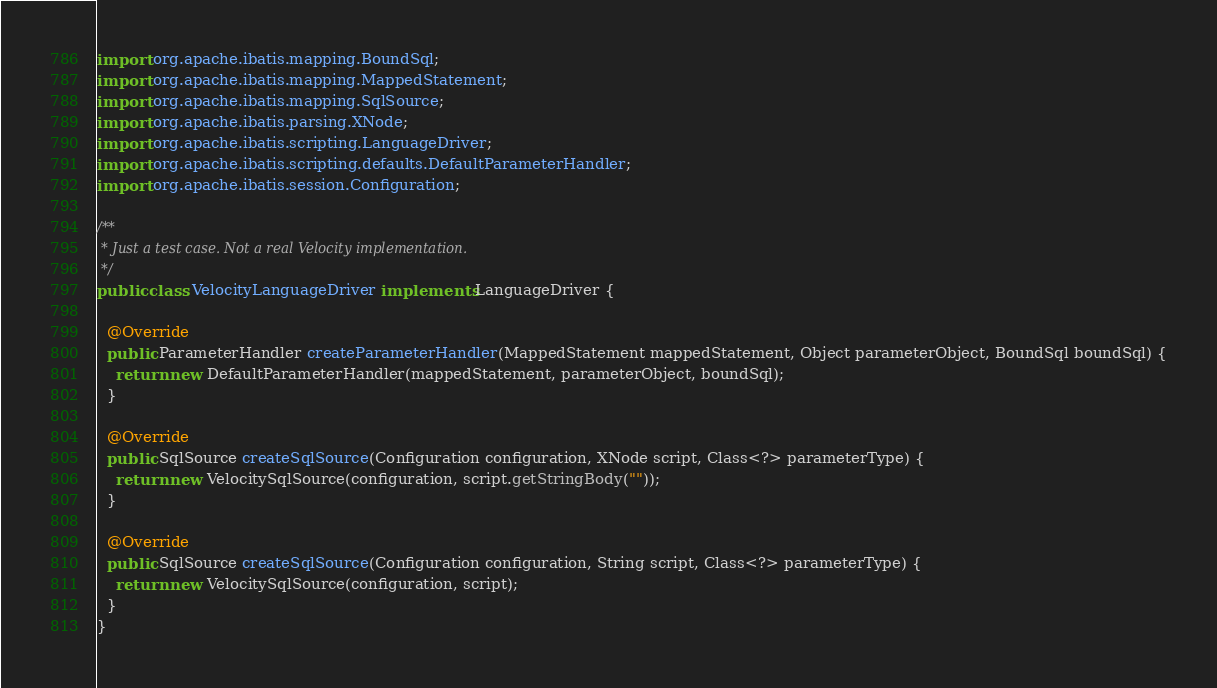Convert code to text. <code><loc_0><loc_0><loc_500><loc_500><_Java_>import org.apache.ibatis.mapping.BoundSql;
import org.apache.ibatis.mapping.MappedStatement;
import org.apache.ibatis.mapping.SqlSource;
import org.apache.ibatis.parsing.XNode;
import org.apache.ibatis.scripting.LanguageDriver;
import org.apache.ibatis.scripting.defaults.DefaultParameterHandler;
import org.apache.ibatis.session.Configuration;

/**
 * Just a test case. Not a real Velocity implementation.
 */
public class VelocityLanguageDriver implements LanguageDriver {

  @Override
  public ParameterHandler createParameterHandler(MappedStatement mappedStatement, Object parameterObject, BoundSql boundSql) {
    return new DefaultParameterHandler(mappedStatement, parameterObject, boundSql);
  }

  @Override
  public SqlSource createSqlSource(Configuration configuration, XNode script, Class<?> parameterType) {
    return new VelocitySqlSource(configuration, script.getStringBody(""));
  }

  @Override
  public SqlSource createSqlSource(Configuration configuration, String script, Class<?> parameterType) {
    return new VelocitySqlSource(configuration, script);
  }
}
</code> 